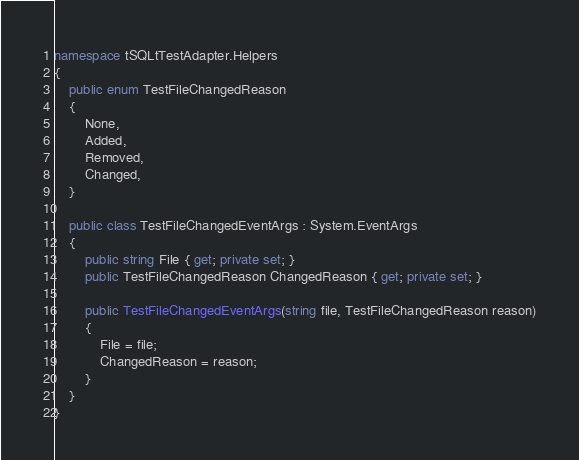Convert code to text. <code><loc_0><loc_0><loc_500><loc_500><_C#_>namespace tSQLtTestAdapter.Helpers
{
    public enum TestFileChangedReason
    {
        None,
        Added,
        Removed,
        Changed,
    }

    public class TestFileChangedEventArgs : System.EventArgs
    {
        public string File { get; private set; }
        public TestFileChangedReason ChangedReason { get; private set; }

        public TestFileChangedEventArgs(string file, TestFileChangedReason reason)
        {
            File = file;
            ChangedReason = reason;
        }
    }
}</code> 